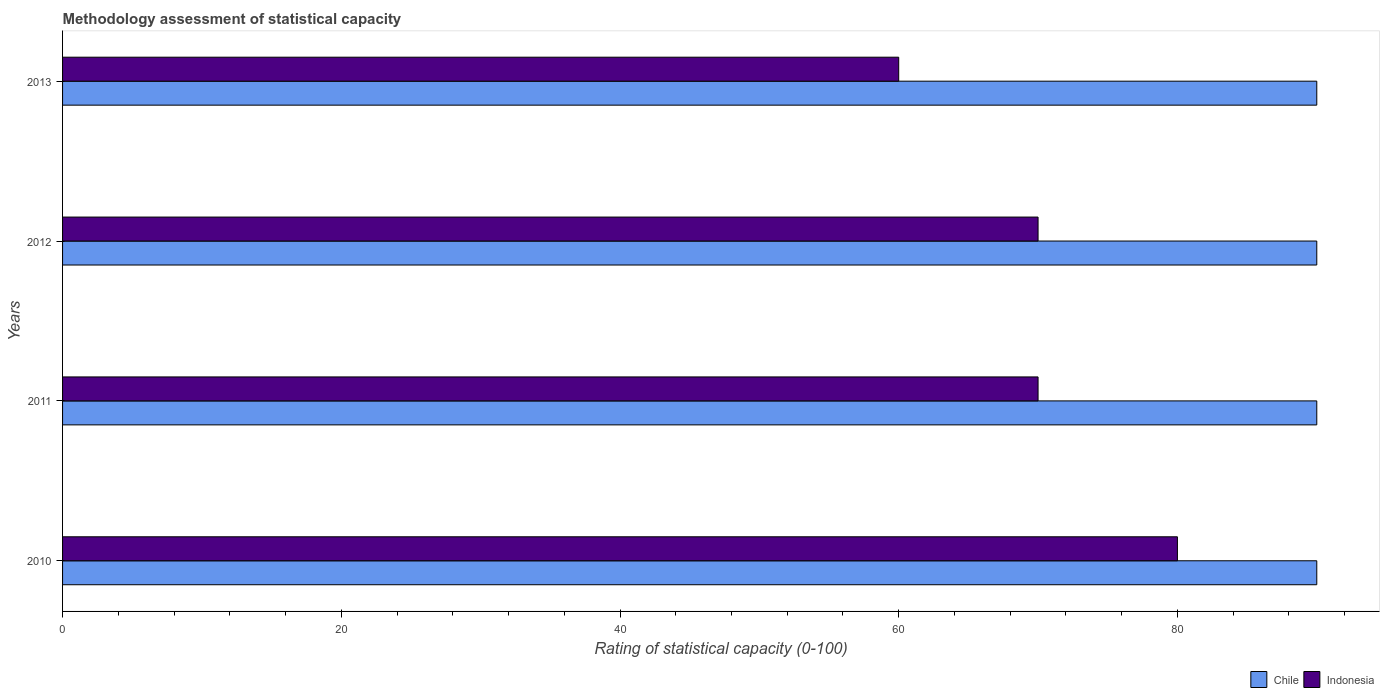Are the number of bars on each tick of the Y-axis equal?
Provide a short and direct response. Yes. How many bars are there on the 3rd tick from the top?
Keep it short and to the point. 2. How many bars are there on the 1st tick from the bottom?
Your answer should be very brief. 2. What is the label of the 4th group of bars from the top?
Ensure brevity in your answer.  2010. In how many cases, is the number of bars for a given year not equal to the number of legend labels?
Your answer should be very brief. 0. What is the rating of statistical capacity in Chile in 2010?
Offer a terse response. 90. Across all years, what is the maximum rating of statistical capacity in Indonesia?
Provide a short and direct response. 80. Across all years, what is the minimum rating of statistical capacity in Indonesia?
Provide a succinct answer. 60. In which year was the rating of statistical capacity in Chile minimum?
Keep it short and to the point. 2010. What is the total rating of statistical capacity in Chile in the graph?
Keep it short and to the point. 360. What is the difference between the rating of statistical capacity in Chile in 2011 and the rating of statistical capacity in Indonesia in 2013?
Make the answer very short. 30. In the year 2011, what is the difference between the rating of statistical capacity in Indonesia and rating of statistical capacity in Chile?
Offer a very short reply. -20. In how many years, is the rating of statistical capacity in Chile greater than 28 ?
Offer a very short reply. 4. What is the ratio of the rating of statistical capacity in Indonesia in 2011 to that in 2012?
Make the answer very short. 1. Is the rating of statistical capacity in Indonesia in 2012 less than that in 2013?
Offer a terse response. No. What is the difference between the highest and the lowest rating of statistical capacity in Chile?
Provide a short and direct response. 0. Is the sum of the rating of statistical capacity in Indonesia in 2011 and 2012 greater than the maximum rating of statistical capacity in Chile across all years?
Your answer should be very brief. Yes. What does the 1st bar from the bottom in 2013 represents?
Offer a very short reply. Chile. How many bars are there?
Offer a very short reply. 8. Are all the bars in the graph horizontal?
Your answer should be very brief. Yes. What is the difference between two consecutive major ticks on the X-axis?
Provide a succinct answer. 20. Are the values on the major ticks of X-axis written in scientific E-notation?
Give a very brief answer. No. Does the graph contain grids?
Offer a very short reply. No. Where does the legend appear in the graph?
Your answer should be very brief. Bottom right. How many legend labels are there?
Keep it short and to the point. 2. How are the legend labels stacked?
Give a very brief answer. Horizontal. What is the title of the graph?
Offer a very short reply. Methodology assessment of statistical capacity. What is the label or title of the X-axis?
Your answer should be compact. Rating of statistical capacity (0-100). What is the Rating of statistical capacity (0-100) of Chile in 2010?
Offer a very short reply. 90. What is the Rating of statistical capacity (0-100) in Indonesia in 2012?
Offer a very short reply. 70. What is the Rating of statistical capacity (0-100) of Chile in 2013?
Provide a short and direct response. 90. What is the Rating of statistical capacity (0-100) of Indonesia in 2013?
Your answer should be compact. 60. Across all years, what is the maximum Rating of statistical capacity (0-100) of Chile?
Your answer should be compact. 90. Across all years, what is the minimum Rating of statistical capacity (0-100) in Chile?
Provide a succinct answer. 90. Across all years, what is the minimum Rating of statistical capacity (0-100) in Indonesia?
Give a very brief answer. 60. What is the total Rating of statistical capacity (0-100) of Chile in the graph?
Your answer should be compact. 360. What is the total Rating of statistical capacity (0-100) of Indonesia in the graph?
Your answer should be very brief. 280. What is the difference between the Rating of statistical capacity (0-100) in Chile in 2010 and that in 2012?
Your response must be concise. 0. What is the difference between the Rating of statistical capacity (0-100) of Indonesia in 2010 and that in 2012?
Keep it short and to the point. 10. What is the difference between the Rating of statistical capacity (0-100) in Chile in 2011 and that in 2012?
Provide a succinct answer. 0. What is the difference between the Rating of statistical capacity (0-100) of Indonesia in 2011 and that in 2012?
Your answer should be compact. 0. What is the difference between the Rating of statistical capacity (0-100) in Chile in 2012 and that in 2013?
Provide a succinct answer. 0. What is the difference between the Rating of statistical capacity (0-100) in Indonesia in 2012 and that in 2013?
Keep it short and to the point. 10. What is the difference between the Rating of statistical capacity (0-100) of Chile in 2010 and the Rating of statistical capacity (0-100) of Indonesia in 2012?
Give a very brief answer. 20. What is the difference between the Rating of statistical capacity (0-100) of Chile in 2011 and the Rating of statistical capacity (0-100) of Indonesia in 2013?
Provide a short and direct response. 30. What is the average Rating of statistical capacity (0-100) in Indonesia per year?
Provide a short and direct response. 70. In the year 2010, what is the difference between the Rating of statistical capacity (0-100) in Chile and Rating of statistical capacity (0-100) in Indonesia?
Offer a very short reply. 10. What is the ratio of the Rating of statistical capacity (0-100) of Chile in 2010 to that in 2011?
Your answer should be very brief. 1. What is the ratio of the Rating of statistical capacity (0-100) in Chile in 2010 to that in 2012?
Provide a short and direct response. 1. What is the ratio of the Rating of statistical capacity (0-100) in Indonesia in 2010 to that in 2013?
Provide a succinct answer. 1.33. What is the ratio of the Rating of statistical capacity (0-100) of Indonesia in 2011 to that in 2012?
Your response must be concise. 1. What is the ratio of the Rating of statistical capacity (0-100) of Chile in 2011 to that in 2013?
Your response must be concise. 1. What is the ratio of the Rating of statistical capacity (0-100) of Indonesia in 2011 to that in 2013?
Ensure brevity in your answer.  1.17. What is the ratio of the Rating of statistical capacity (0-100) of Chile in 2012 to that in 2013?
Your response must be concise. 1. What is the difference between the highest and the lowest Rating of statistical capacity (0-100) of Chile?
Provide a succinct answer. 0. 